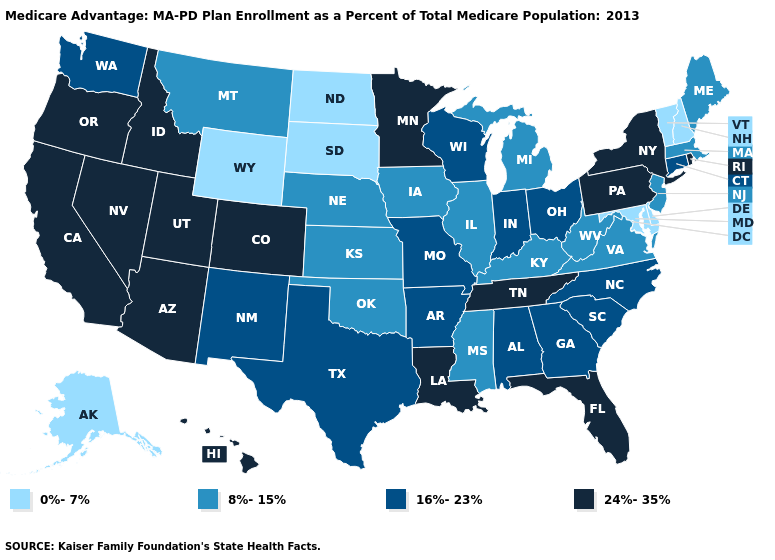Which states have the lowest value in the USA?
Concise answer only. Alaska, Delaware, Maryland, North Dakota, New Hampshire, South Dakota, Vermont, Wyoming. What is the value of Pennsylvania?
Write a very short answer. 24%-35%. Among the states that border Arizona , does New Mexico have the lowest value?
Quick response, please. Yes. What is the highest value in the USA?
Give a very brief answer. 24%-35%. Which states have the lowest value in the USA?
Write a very short answer. Alaska, Delaware, Maryland, North Dakota, New Hampshire, South Dakota, Vermont, Wyoming. Among the states that border New Hampshire , does Maine have the highest value?
Quick response, please. Yes. What is the lowest value in the South?
Concise answer only. 0%-7%. What is the lowest value in states that border Montana?
Write a very short answer. 0%-7%. Name the states that have a value in the range 0%-7%?
Keep it brief. Alaska, Delaware, Maryland, North Dakota, New Hampshire, South Dakota, Vermont, Wyoming. What is the value of Virginia?
Be succinct. 8%-15%. Among the states that border Tennessee , which have the lowest value?
Give a very brief answer. Kentucky, Mississippi, Virginia. Which states hav the highest value in the South?
Give a very brief answer. Florida, Louisiana, Tennessee. What is the value of Pennsylvania?
Quick response, please. 24%-35%. Name the states that have a value in the range 16%-23%?
Concise answer only. Alabama, Arkansas, Connecticut, Georgia, Indiana, Missouri, North Carolina, New Mexico, Ohio, South Carolina, Texas, Washington, Wisconsin. 